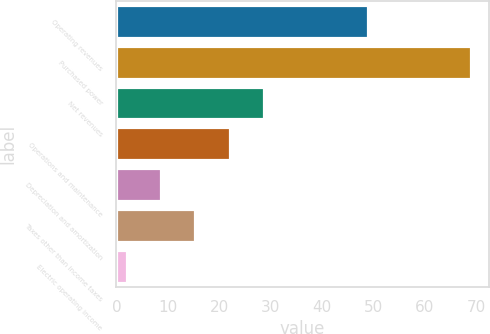<chart> <loc_0><loc_0><loc_500><loc_500><bar_chart><fcel>Operating revenues<fcel>Purchased power<fcel>Net revenues<fcel>Operations and maintenance<fcel>Depreciation and amortization<fcel>Taxes other than income taxes<fcel>Electric operating income<nl><fcel>49<fcel>69<fcel>28.8<fcel>22.1<fcel>8.7<fcel>15.4<fcel>2<nl></chart> 